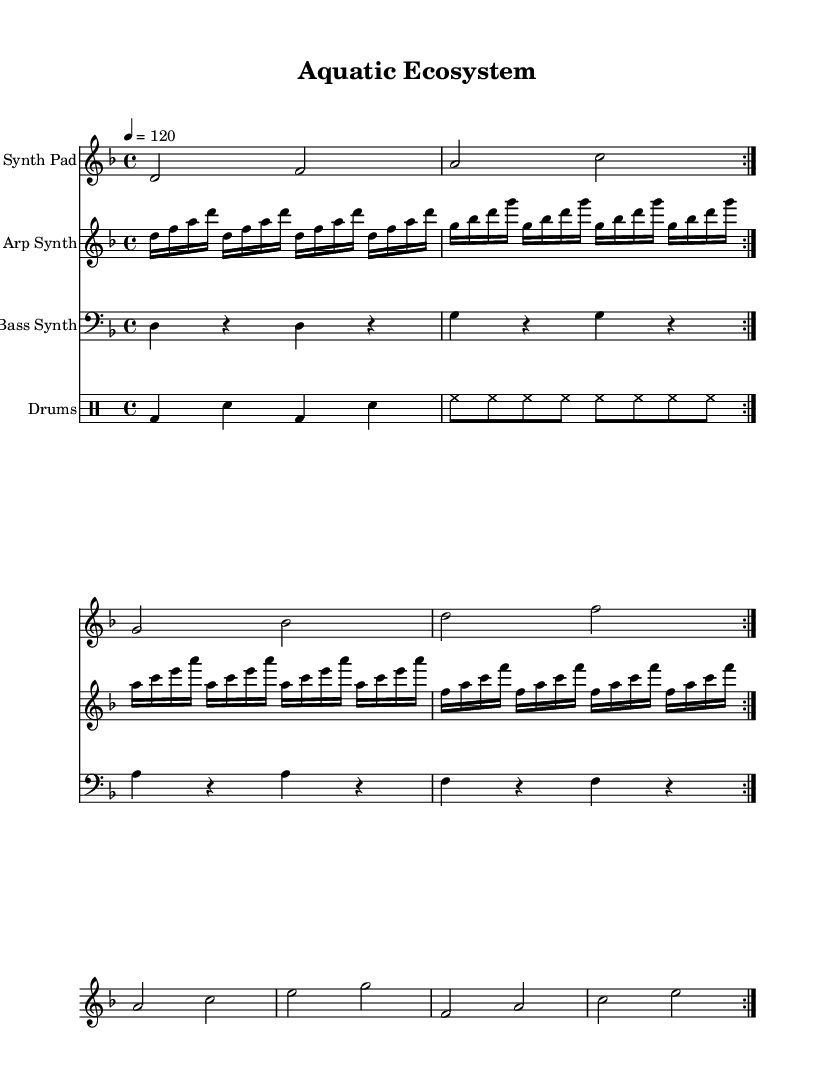What is the key signature of this music? The key signature is D minor, which is evident from the presence of one flat (B flat) noted at the beginning of the score.
Answer: D minor What is the time signature of the music? The time signature is 4/4, indicated at the beginning of the score, suggesting four beats in each measure and a quarter note receives one beat.
Answer: 4/4 What is the tempo marking of this piece? The tempo is marked at 120 beats per minute, as shown in the tempo indication at the beginning of the score.
Answer: 120 How many measures are repeated in the synth pad section? The synth pad section is repeated for two measures, indicated by the "volta 2" marking, which shows the repeating section in the score.
Answer: 2 What rhythmic pattern is used in the bass synth? The bass synth uses a pattern with quarter notes separated by rests, creating a distinctive pulsing rhythm.
Answer: Quarter notes with rests Which instrument has the fastest note values in this piece? The arp synth contains the fastest note values, using sixteenth notes consistently throughout its section.
Answer: Arp Synth What type of drum pattern is utilized in this piece? The drum pattern consists of bass drum and snare combinations, along with continuous hi-hat hits, creating a typical dance rhythm.
Answer: Bass drum and snare 